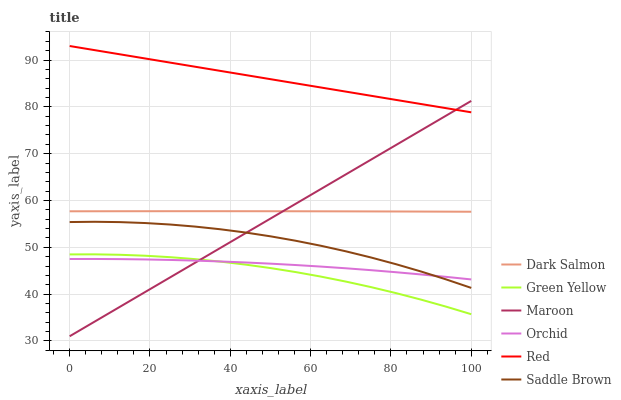Does Green Yellow have the minimum area under the curve?
Answer yes or no. Yes. Does Red have the maximum area under the curve?
Answer yes or no. Yes. Does Maroon have the minimum area under the curve?
Answer yes or no. No. Does Maroon have the maximum area under the curve?
Answer yes or no. No. Is Red the smoothest?
Answer yes or no. Yes. Is Saddle Brown the roughest?
Answer yes or no. Yes. Is Maroon the smoothest?
Answer yes or no. No. Is Maroon the roughest?
Answer yes or no. No. Does Green Yellow have the lowest value?
Answer yes or no. No. Does Red have the highest value?
Answer yes or no. Yes. Does Maroon have the highest value?
Answer yes or no. No. Is Orchid less than Red?
Answer yes or no. Yes. Is Dark Salmon greater than Green Yellow?
Answer yes or no. Yes. Does Orchid intersect Red?
Answer yes or no. No. 